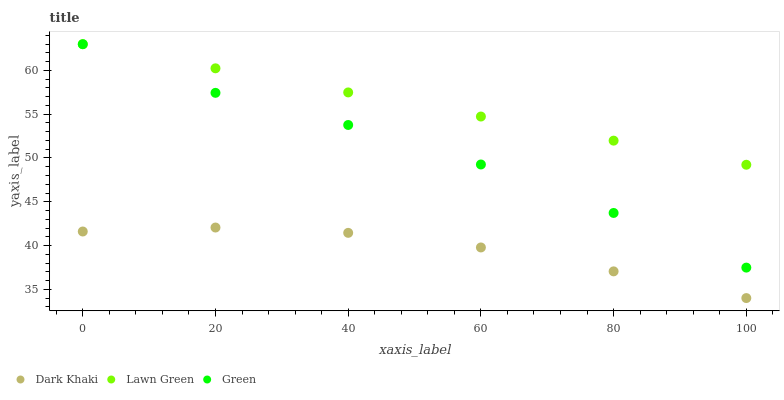Does Dark Khaki have the minimum area under the curve?
Answer yes or no. Yes. Does Lawn Green have the maximum area under the curve?
Answer yes or no. Yes. Does Green have the minimum area under the curve?
Answer yes or no. No. Does Green have the maximum area under the curve?
Answer yes or no. No. Is Lawn Green the smoothest?
Answer yes or no. Yes. Is Green the roughest?
Answer yes or no. Yes. Is Green the smoothest?
Answer yes or no. No. Is Lawn Green the roughest?
Answer yes or no. No. Does Dark Khaki have the lowest value?
Answer yes or no. Yes. Does Green have the lowest value?
Answer yes or no. No. Does Green have the highest value?
Answer yes or no. Yes. Is Dark Khaki less than Green?
Answer yes or no. Yes. Is Green greater than Dark Khaki?
Answer yes or no. Yes. Does Green intersect Lawn Green?
Answer yes or no. Yes. Is Green less than Lawn Green?
Answer yes or no. No. Is Green greater than Lawn Green?
Answer yes or no. No. Does Dark Khaki intersect Green?
Answer yes or no. No. 